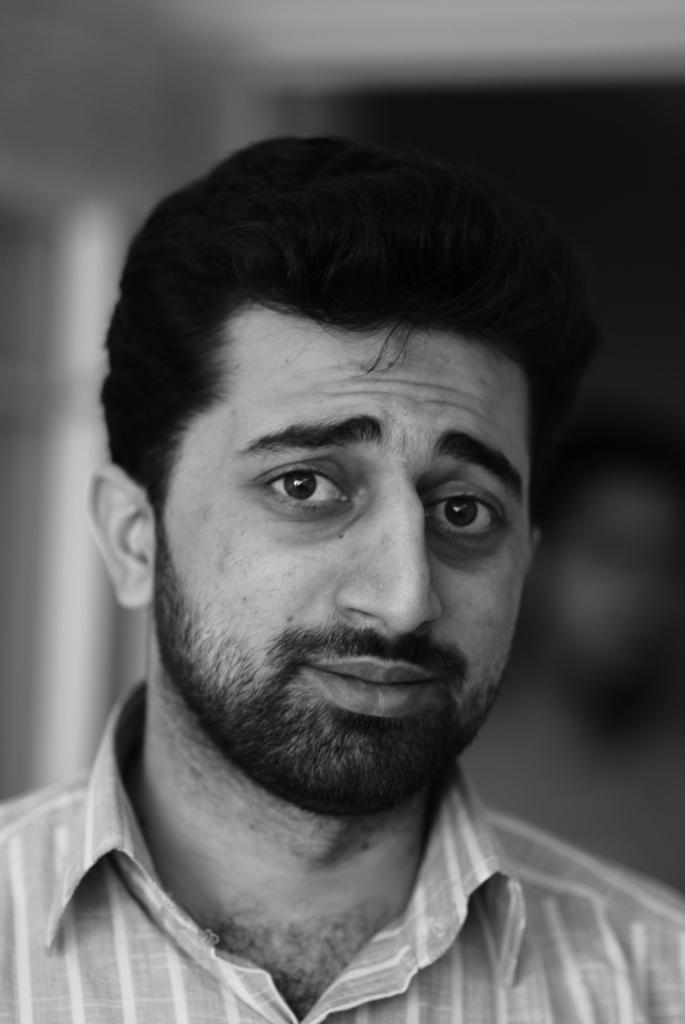What is the color scheme of the picture? The picture is black and white. Can you describe the main subject in the image? There is a person in the picture. What is the appearance of the background in the image? The background of the picture is blurred. How many pages are visible in the library in the image? There is no library or pages present in the image; it is a black and white picture featuring a person with a blurred background. 